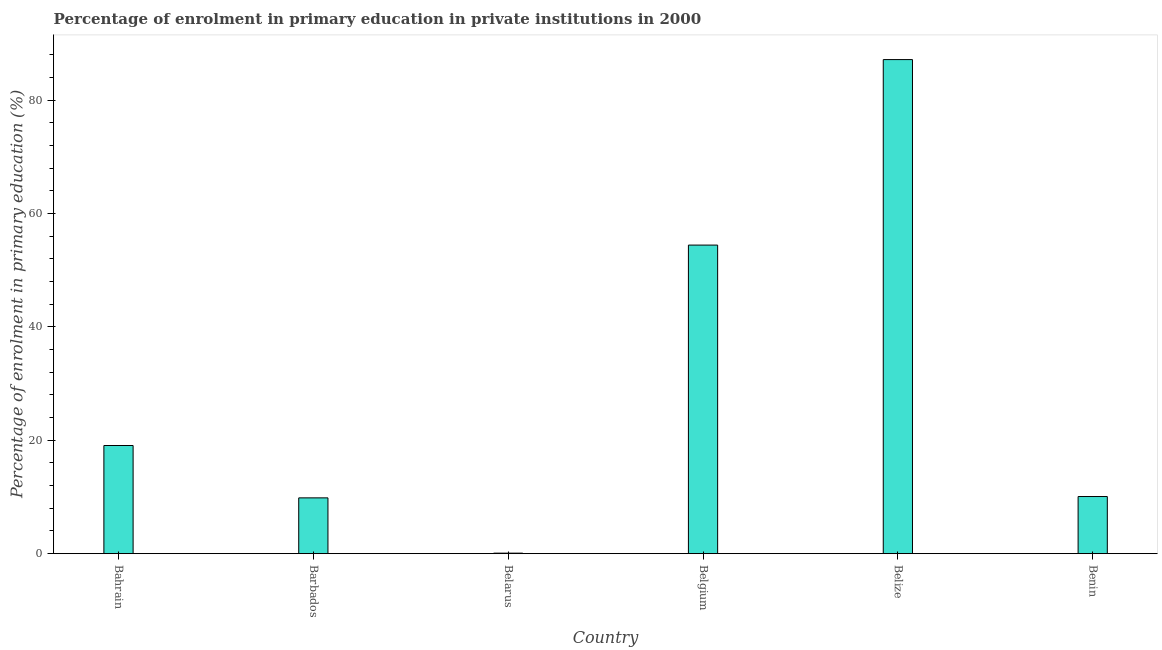Does the graph contain grids?
Provide a succinct answer. No. What is the title of the graph?
Offer a terse response. Percentage of enrolment in primary education in private institutions in 2000. What is the label or title of the X-axis?
Offer a very short reply. Country. What is the label or title of the Y-axis?
Provide a short and direct response. Percentage of enrolment in primary education (%). What is the enrolment percentage in primary education in Belgium?
Your answer should be compact. 54.45. Across all countries, what is the maximum enrolment percentage in primary education?
Provide a succinct answer. 87.18. Across all countries, what is the minimum enrolment percentage in primary education?
Keep it short and to the point. 0.09. In which country was the enrolment percentage in primary education maximum?
Ensure brevity in your answer.  Belize. In which country was the enrolment percentage in primary education minimum?
Provide a succinct answer. Belarus. What is the sum of the enrolment percentage in primary education?
Your answer should be compact. 180.73. What is the difference between the enrolment percentage in primary education in Barbados and Belize?
Ensure brevity in your answer.  -77.34. What is the average enrolment percentage in primary education per country?
Provide a short and direct response. 30.12. What is the median enrolment percentage in primary education?
Ensure brevity in your answer.  14.58. What is the ratio of the enrolment percentage in primary education in Belize to that in Benin?
Give a very brief answer. 8.65. Is the difference between the enrolment percentage in primary education in Barbados and Belarus greater than the difference between any two countries?
Your response must be concise. No. What is the difference between the highest and the second highest enrolment percentage in primary education?
Your answer should be very brief. 32.74. What is the difference between the highest and the lowest enrolment percentage in primary education?
Give a very brief answer. 87.1. How many bars are there?
Offer a terse response. 6. Are all the bars in the graph horizontal?
Offer a terse response. No. How many countries are there in the graph?
Make the answer very short. 6. What is the Percentage of enrolment in primary education (%) of Bahrain?
Your response must be concise. 19.08. What is the Percentage of enrolment in primary education (%) in Barbados?
Provide a succinct answer. 9.84. What is the Percentage of enrolment in primary education (%) in Belarus?
Your response must be concise. 0.09. What is the Percentage of enrolment in primary education (%) in Belgium?
Make the answer very short. 54.45. What is the Percentage of enrolment in primary education (%) of Belize?
Ensure brevity in your answer.  87.18. What is the Percentage of enrolment in primary education (%) of Benin?
Offer a very short reply. 10.08. What is the difference between the Percentage of enrolment in primary education (%) in Bahrain and Barbados?
Your answer should be very brief. 9.24. What is the difference between the Percentage of enrolment in primary education (%) in Bahrain and Belarus?
Give a very brief answer. 18.99. What is the difference between the Percentage of enrolment in primary education (%) in Bahrain and Belgium?
Ensure brevity in your answer.  -35.37. What is the difference between the Percentage of enrolment in primary education (%) in Bahrain and Belize?
Your answer should be compact. -68.1. What is the difference between the Percentage of enrolment in primary education (%) in Bahrain and Benin?
Provide a short and direct response. 9. What is the difference between the Percentage of enrolment in primary education (%) in Barbados and Belarus?
Provide a short and direct response. 9.75. What is the difference between the Percentage of enrolment in primary education (%) in Barbados and Belgium?
Offer a very short reply. -44.61. What is the difference between the Percentage of enrolment in primary education (%) in Barbados and Belize?
Your answer should be compact. -77.34. What is the difference between the Percentage of enrolment in primary education (%) in Barbados and Benin?
Your answer should be very brief. -0.24. What is the difference between the Percentage of enrolment in primary education (%) in Belarus and Belgium?
Your answer should be compact. -54.36. What is the difference between the Percentage of enrolment in primary education (%) in Belarus and Belize?
Your answer should be very brief. -87.1. What is the difference between the Percentage of enrolment in primary education (%) in Belarus and Benin?
Your answer should be very brief. -9.99. What is the difference between the Percentage of enrolment in primary education (%) in Belgium and Belize?
Offer a very short reply. -32.74. What is the difference between the Percentage of enrolment in primary education (%) in Belgium and Benin?
Your response must be concise. 44.37. What is the difference between the Percentage of enrolment in primary education (%) in Belize and Benin?
Provide a short and direct response. 77.1. What is the ratio of the Percentage of enrolment in primary education (%) in Bahrain to that in Barbados?
Your response must be concise. 1.94. What is the ratio of the Percentage of enrolment in primary education (%) in Bahrain to that in Belarus?
Ensure brevity in your answer.  214.72. What is the ratio of the Percentage of enrolment in primary education (%) in Bahrain to that in Belgium?
Ensure brevity in your answer.  0.35. What is the ratio of the Percentage of enrolment in primary education (%) in Bahrain to that in Belize?
Keep it short and to the point. 0.22. What is the ratio of the Percentage of enrolment in primary education (%) in Bahrain to that in Benin?
Your answer should be very brief. 1.89. What is the ratio of the Percentage of enrolment in primary education (%) in Barbados to that in Belarus?
Your answer should be very brief. 110.75. What is the ratio of the Percentage of enrolment in primary education (%) in Barbados to that in Belgium?
Provide a short and direct response. 0.18. What is the ratio of the Percentage of enrolment in primary education (%) in Barbados to that in Belize?
Keep it short and to the point. 0.11. What is the ratio of the Percentage of enrolment in primary education (%) in Belarus to that in Belgium?
Ensure brevity in your answer.  0. What is the ratio of the Percentage of enrolment in primary education (%) in Belarus to that in Benin?
Offer a very short reply. 0.01. What is the ratio of the Percentage of enrolment in primary education (%) in Belgium to that in Belize?
Your answer should be compact. 0.62. What is the ratio of the Percentage of enrolment in primary education (%) in Belgium to that in Benin?
Give a very brief answer. 5.4. What is the ratio of the Percentage of enrolment in primary education (%) in Belize to that in Benin?
Make the answer very short. 8.65. 